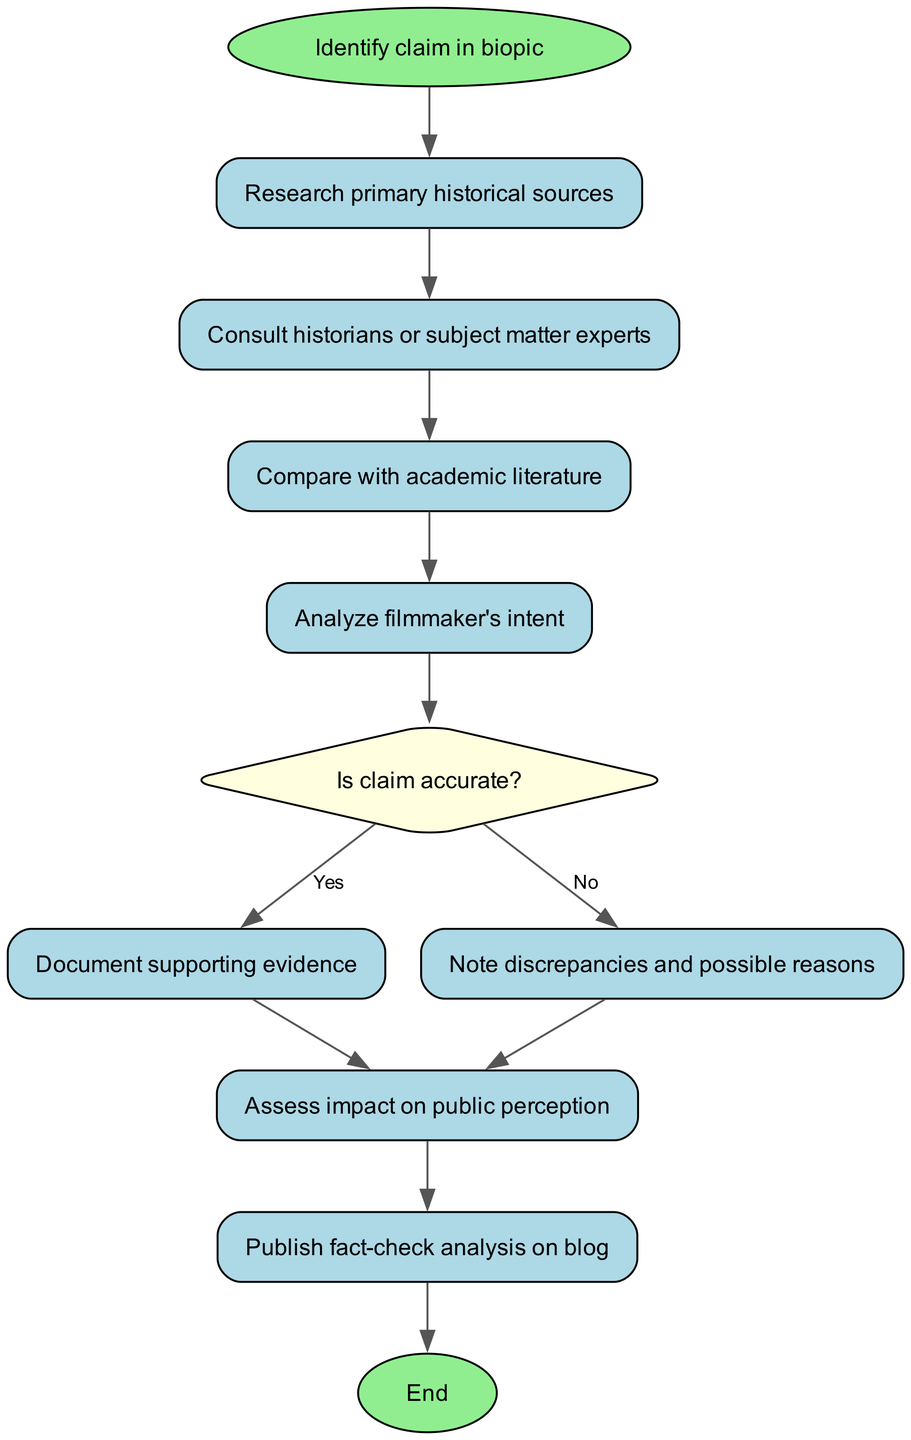What is the first step in the workflow? The first step in the workflow is represented by the "start" node, which states "Identify claim in biopic." This is the entry point of the flowchart indicating what initiates the fact-checking process.
Answer: Identify claim in biopic How many nodes are there in total? The total number of nodes is calculated by counting all the unique elements listed in the diagram. There are 11 nodes described in the data provided.
Answer: 11 What is the last step before publishing the analysis? The last step before publishing the analysis is from the "impact" node, which leads to the "publish" node. This indicates that assessing the impact on public perception precedes the publication of the analysis.
Answer: Assess impact on public perception What are the two outcomes of the decision node based on the claim's accuracy? The decision node has two outcomes labeled "Yes" if the claim is accurate, and "No" if the claim is not accurate. These outcomes guide the subsequent actions of documenting evidence or noting discrepancies.
Answer: Yes, No Which node directly follows the comparison with academic literature? The node that directly follows the comparison with academic literature is labeled "Analyze filmmaker's intent." This indicates that after comparing claims with literature, one must analyze the intent behind the filmmaking.
Answer: Analyze filmmaker's intent How many connections lead from the decision node, and what do they signify? There are two connections leading from the decision node: one labeled "Yes" leading to "Document supporting evidence," and one labeled "No" leading to "Note discrepancies and possible reasons." They signify the next steps based on whether the claim is assessed as accurate or inaccurate.
Answer: Two connections: Yes, No What does the workflow conclude with? The workflow concludes with the "end" node, which signifies the completion of the fact-checking process after publishing the analysis on the blog.
Answer: End Which node requires consulting historians or subject matter experts? The node that requires consulting historians or subject matter experts is the "consult" node. This step emphasizes the need for expert advice to validate historical claims.
Answer: Consult historians or subject matter experts What should be documented if the claim is found to be accurate? If the claim is found to be accurate, the next step is to "Document supporting evidence." This emphasizes the need for compiling proof of the claim's accuracy for transparency and credibility.
Answer: Document supporting evidence 